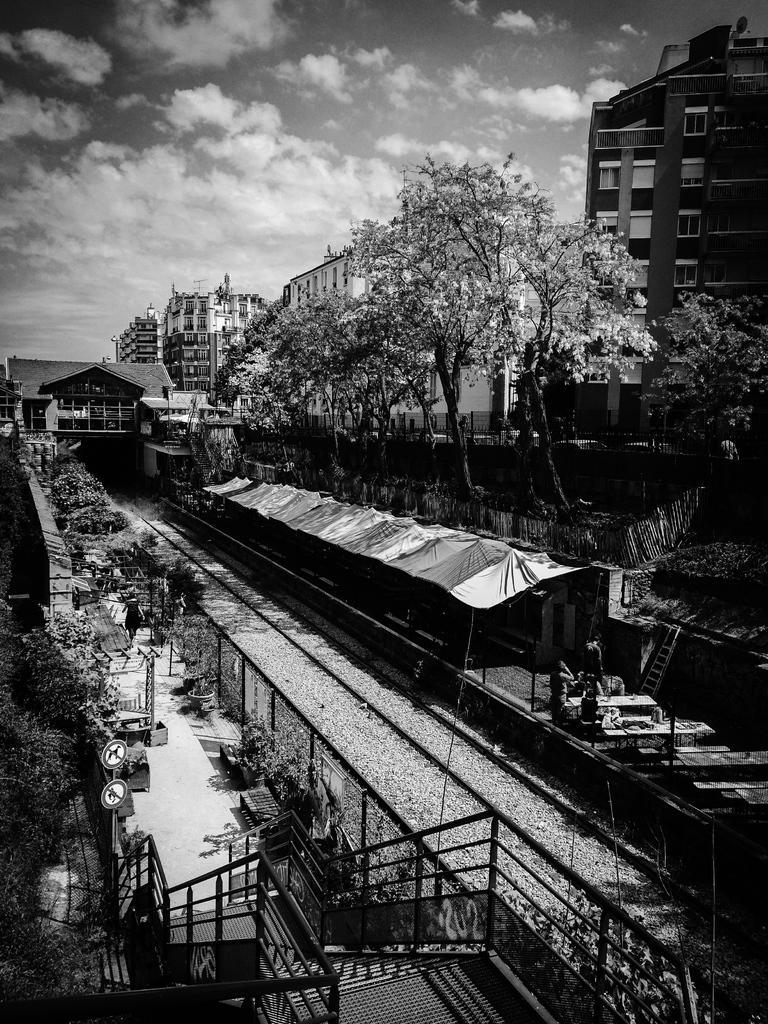Could you give a brief overview of what you see in this image? This image is a black and white image. This image is taken outdoors. At the top of the image there is a sky with clouds. At the bottom of the image there is a staircase with railings. On the left side of the image there are a few trees, sign boards and poles and there is a platform. A woman is walking on the platform. On the right side of the image there are a few buildings and trees and there is a platform. There are a few tables and there is a ladder. In the middle of the image there are two railway tracks. 